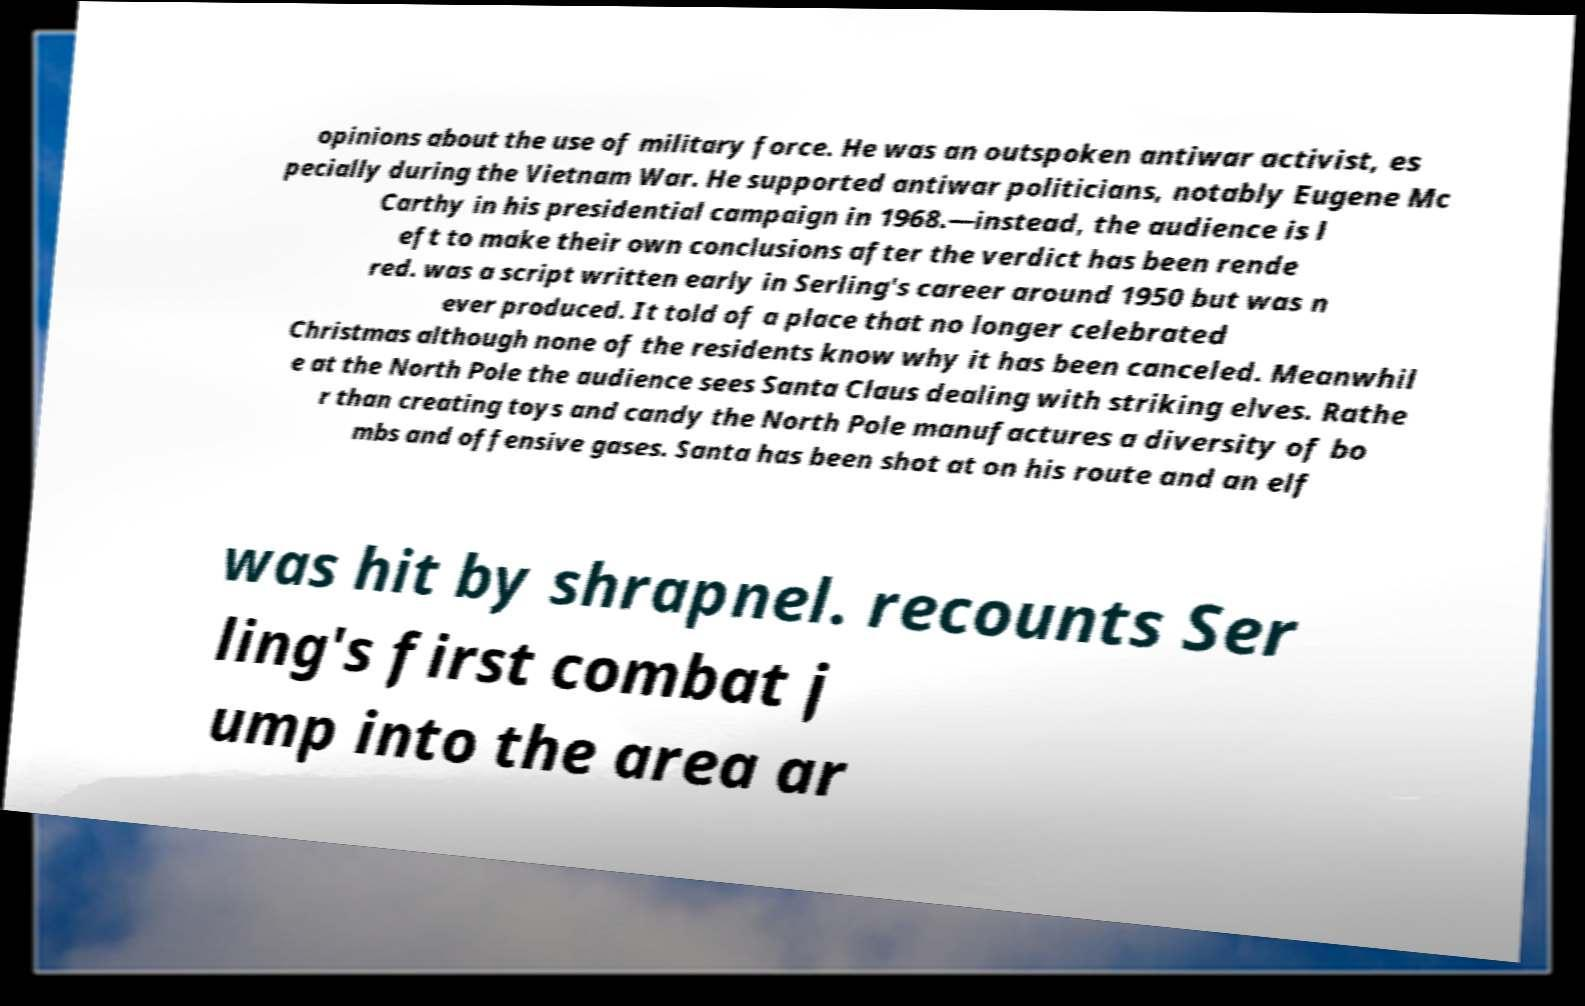There's text embedded in this image that I need extracted. Can you transcribe it verbatim? opinions about the use of military force. He was an outspoken antiwar activist, es pecially during the Vietnam War. He supported antiwar politicians, notably Eugene Mc Carthy in his presidential campaign in 1968.—instead, the audience is l eft to make their own conclusions after the verdict has been rende red. was a script written early in Serling's career around 1950 but was n ever produced. It told of a place that no longer celebrated Christmas although none of the residents know why it has been canceled. Meanwhil e at the North Pole the audience sees Santa Claus dealing with striking elves. Rathe r than creating toys and candy the North Pole manufactures a diversity of bo mbs and offensive gases. Santa has been shot at on his route and an elf was hit by shrapnel. recounts Ser ling's first combat j ump into the area ar 